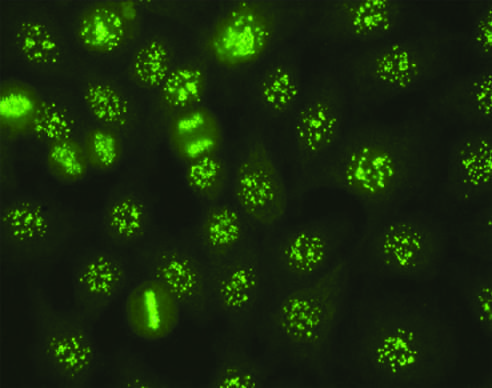s the dark green polypeptides seen in some cases of systemic sclerosis, sjogren syndrome, and other diseases?
Answer the question using a single word or phrase. No 